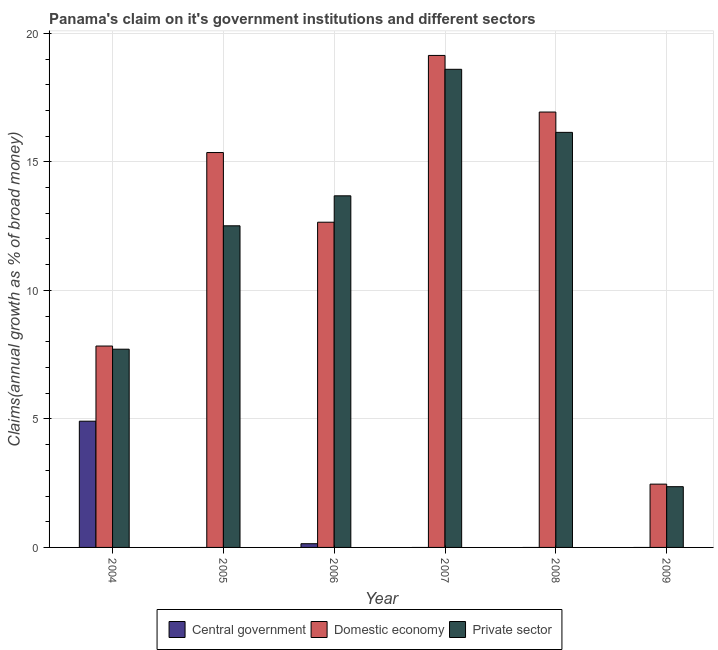How many different coloured bars are there?
Provide a succinct answer. 3. How many bars are there on the 4th tick from the left?
Make the answer very short. 2. Across all years, what is the maximum percentage of claim on the central government?
Give a very brief answer. 4.91. Across all years, what is the minimum percentage of claim on the central government?
Your answer should be compact. 0. In which year was the percentage of claim on the private sector maximum?
Keep it short and to the point. 2007. What is the total percentage of claim on the domestic economy in the graph?
Provide a succinct answer. 74.39. What is the difference between the percentage of claim on the private sector in 2005 and that in 2006?
Provide a short and direct response. -1.17. What is the difference between the percentage of claim on the private sector in 2006 and the percentage of claim on the central government in 2009?
Offer a very short reply. 11.32. What is the average percentage of claim on the central government per year?
Your response must be concise. 0.84. What is the ratio of the percentage of claim on the domestic economy in 2004 to that in 2009?
Your answer should be very brief. 3.18. Is the percentage of claim on the private sector in 2005 less than that in 2009?
Ensure brevity in your answer.  No. What is the difference between the highest and the second highest percentage of claim on the private sector?
Offer a very short reply. 2.45. What is the difference between the highest and the lowest percentage of claim on the domestic economy?
Provide a succinct answer. 16.68. In how many years, is the percentage of claim on the domestic economy greater than the average percentage of claim on the domestic economy taken over all years?
Your answer should be very brief. 4. How many years are there in the graph?
Offer a very short reply. 6. Does the graph contain any zero values?
Make the answer very short. Yes. Does the graph contain grids?
Give a very brief answer. Yes. How are the legend labels stacked?
Offer a very short reply. Horizontal. What is the title of the graph?
Provide a succinct answer. Panama's claim on it's government institutions and different sectors. Does "Injury" appear as one of the legend labels in the graph?
Keep it short and to the point. No. What is the label or title of the X-axis?
Make the answer very short. Year. What is the label or title of the Y-axis?
Give a very brief answer. Claims(annual growth as % of broad money). What is the Claims(annual growth as % of broad money) in Central government in 2004?
Offer a terse response. 4.91. What is the Claims(annual growth as % of broad money) in Domestic economy in 2004?
Your response must be concise. 7.83. What is the Claims(annual growth as % of broad money) of Private sector in 2004?
Your response must be concise. 7.71. What is the Claims(annual growth as % of broad money) of Domestic economy in 2005?
Offer a terse response. 15.36. What is the Claims(annual growth as % of broad money) in Private sector in 2005?
Offer a terse response. 12.51. What is the Claims(annual growth as % of broad money) in Central government in 2006?
Make the answer very short. 0.14. What is the Claims(annual growth as % of broad money) of Domestic economy in 2006?
Provide a succinct answer. 12.65. What is the Claims(annual growth as % of broad money) in Private sector in 2006?
Your answer should be very brief. 13.68. What is the Claims(annual growth as % of broad money) of Domestic economy in 2007?
Your answer should be very brief. 19.14. What is the Claims(annual growth as % of broad money) of Private sector in 2007?
Your response must be concise. 18.6. What is the Claims(annual growth as % of broad money) in Domestic economy in 2008?
Make the answer very short. 16.94. What is the Claims(annual growth as % of broad money) of Private sector in 2008?
Offer a terse response. 16.15. What is the Claims(annual growth as % of broad money) of Domestic economy in 2009?
Offer a terse response. 2.46. What is the Claims(annual growth as % of broad money) of Private sector in 2009?
Your response must be concise. 2.36. Across all years, what is the maximum Claims(annual growth as % of broad money) in Central government?
Make the answer very short. 4.91. Across all years, what is the maximum Claims(annual growth as % of broad money) in Domestic economy?
Your answer should be compact. 19.14. Across all years, what is the maximum Claims(annual growth as % of broad money) in Private sector?
Keep it short and to the point. 18.6. Across all years, what is the minimum Claims(annual growth as % of broad money) of Central government?
Offer a terse response. 0. Across all years, what is the minimum Claims(annual growth as % of broad money) of Domestic economy?
Your response must be concise. 2.46. Across all years, what is the minimum Claims(annual growth as % of broad money) of Private sector?
Offer a terse response. 2.36. What is the total Claims(annual growth as % of broad money) in Central government in the graph?
Offer a very short reply. 5.06. What is the total Claims(annual growth as % of broad money) in Domestic economy in the graph?
Provide a short and direct response. 74.39. What is the total Claims(annual growth as % of broad money) of Private sector in the graph?
Offer a terse response. 71.02. What is the difference between the Claims(annual growth as % of broad money) of Domestic economy in 2004 and that in 2005?
Your response must be concise. -7.53. What is the difference between the Claims(annual growth as % of broad money) of Central government in 2004 and that in 2006?
Keep it short and to the point. 4.77. What is the difference between the Claims(annual growth as % of broad money) in Domestic economy in 2004 and that in 2006?
Offer a very short reply. -4.82. What is the difference between the Claims(annual growth as % of broad money) in Private sector in 2004 and that in 2006?
Keep it short and to the point. -5.97. What is the difference between the Claims(annual growth as % of broad money) of Domestic economy in 2004 and that in 2007?
Ensure brevity in your answer.  -11.31. What is the difference between the Claims(annual growth as % of broad money) in Private sector in 2004 and that in 2007?
Offer a very short reply. -10.89. What is the difference between the Claims(annual growth as % of broad money) in Domestic economy in 2004 and that in 2008?
Give a very brief answer. -9.1. What is the difference between the Claims(annual growth as % of broad money) of Private sector in 2004 and that in 2008?
Offer a terse response. -8.44. What is the difference between the Claims(annual growth as % of broad money) in Domestic economy in 2004 and that in 2009?
Make the answer very short. 5.37. What is the difference between the Claims(annual growth as % of broad money) of Private sector in 2004 and that in 2009?
Your response must be concise. 5.35. What is the difference between the Claims(annual growth as % of broad money) of Domestic economy in 2005 and that in 2006?
Offer a terse response. 2.71. What is the difference between the Claims(annual growth as % of broad money) in Private sector in 2005 and that in 2006?
Provide a short and direct response. -1.17. What is the difference between the Claims(annual growth as % of broad money) in Domestic economy in 2005 and that in 2007?
Provide a succinct answer. -3.78. What is the difference between the Claims(annual growth as % of broad money) in Private sector in 2005 and that in 2007?
Your answer should be very brief. -6.09. What is the difference between the Claims(annual growth as % of broad money) in Domestic economy in 2005 and that in 2008?
Make the answer very short. -1.58. What is the difference between the Claims(annual growth as % of broad money) in Private sector in 2005 and that in 2008?
Your answer should be very brief. -3.64. What is the difference between the Claims(annual growth as % of broad money) in Domestic economy in 2005 and that in 2009?
Keep it short and to the point. 12.9. What is the difference between the Claims(annual growth as % of broad money) in Private sector in 2005 and that in 2009?
Give a very brief answer. 10.15. What is the difference between the Claims(annual growth as % of broad money) in Domestic economy in 2006 and that in 2007?
Provide a succinct answer. -6.49. What is the difference between the Claims(annual growth as % of broad money) in Private sector in 2006 and that in 2007?
Keep it short and to the point. -4.92. What is the difference between the Claims(annual growth as % of broad money) in Domestic economy in 2006 and that in 2008?
Your answer should be very brief. -4.29. What is the difference between the Claims(annual growth as % of broad money) in Private sector in 2006 and that in 2008?
Your answer should be very brief. -2.47. What is the difference between the Claims(annual growth as % of broad money) of Domestic economy in 2006 and that in 2009?
Your answer should be very brief. 10.19. What is the difference between the Claims(annual growth as % of broad money) in Private sector in 2006 and that in 2009?
Your answer should be compact. 11.32. What is the difference between the Claims(annual growth as % of broad money) in Domestic economy in 2007 and that in 2008?
Your answer should be very brief. 2.2. What is the difference between the Claims(annual growth as % of broad money) of Private sector in 2007 and that in 2008?
Offer a very short reply. 2.45. What is the difference between the Claims(annual growth as % of broad money) of Domestic economy in 2007 and that in 2009?
Provide a short and direct response. 16.68. What is the difference between the Claims(annual growth as % of broad money) of Private sector in 2007 and that in 2009?
Make the answer very short. 16.24. What is the difference between the Claims(annual growth as % of broad money) of Domestic economy in 2008 and that in 2009?
Ensure brevity in your answer.  14.48. What is the difference between the Claims(annual growth as % of broad money) in Private sector in 2008 and that in 2009?
Give a very brief answer. 13.78. What is the difference between the Claims(annual growth as % of broad money) in Central government in 2004 and the Claims(annual growth as % of broad money) in Domestic economy in 2005?
Provide a succinct answer. -10.45. What is the difference between the Claims(annual growth as % of broad money) of Central government in 2004 and the Claims(annual growth as % of broad money) of Private sector in 2005?
Keep it short and to the point. -7.6. What is the difference between the Claims(annual growth as % of broad money) of Domestic economy in 2004 and the Claims(annual growth as % of broad money) of Private sector in 2005?
Offer a terse response. -4.68. What is the difference between the Claims(annual growth as % of broad money) in Central government in 2004 and the Claims(annual growth as % of broad money) in Domestic economy in 2006?
Your response must be concise. -7.74. What is the difference between the Claims(annual growth as % of broad money) of Central government in 2004 and the Claims(annual growth as % of broad money) of Private sector in 2006?
Your response must be concise. -8.77. What is the difference between the Claims(annual growth as % of broad money) in Domestic economy in 2004 and the Claims(annual growth as % of broad money) in Private sector in 2006?
Provide a short and direct response. -5.84. What is the difference between the Claims(annual growth as % of broad money) in Central government in 2004 and the Claims(annual growth as % of broad money) in Domestic economy in 2007?
Offer a very short reply. -14.23. What is the difference between the Claims(annual growth as % of broad money) of Central government in 2004 and the Claims(annual growth as % of broad money) of Private sector in 2007?
Your response must be concise. -13.69. What is the difference between the Claims(annual growth as % of broad money) in Domestic economy in 2004 and the Claims(annual growth as % of broad money) in Private sector in 2007?
Offer a very short reply. -10.77. What is the difference between the Claims(annual growth as % of broad money) in Central government in 2004 and the Claims(annual growth as % of broad money) in Domestic economy in 2008?
Provide a succinct answer. -12.03. What is the difference between the Claims(annual growth as % of broad money) in Central government in 2004 and the Claims(annual growth as % of broad money) in Private sector in 2008?
Provide a succinct answer. -11.24. What is the difference between the Claims(annual growth as % of broad money) of Domestic economy in 2004 and the Claims(annual growth as % of broad money) of Private sector in 2008?
Offer a very short reply. -8.31. What is the difference between the Claims(annual growth as % of broad money) in Central government in 2004 and the Claims(annual growth as % of broad money) in Domestic economy in 2009?
Offer a very short reply. 2.45. What is the difference between the Claims(annual growth as % of broad money) in Central government in 2004 and the Claims(annual growth as % of broad money) in Private sector in 2009?
Your response must be concise. 2.55. What is the difference between the Claims(annual growth as % of broad money) in Domestic economy in 2004 and the Claims(annual growth as % of broad money) in Private sector in 2009?
Provide a short and direct response. 5.47. What is the difference between the Claims(annual growth as % of broad money) in Domestic economy in 2005 and the Claims(annual growth as % of broad money) in Private sector in 2006?
Your answer should be compact. 1.68. What is the difference between the Claims(annual growth as % of broad money) of Domestic economy in 2005 and the Claims(annual growth as % of broad money) of Private sector in 2007?
Your answer should be compact. -3.24. What is the difference between the Claims(annual growth as % of broad money) in Domestic economy in 2005 and the Claims(annual growth as % of broad money) in Private sector in 2008?
Provide a short and direct response. -0.78. What is the difference between the Claims(annual growth as % of broad money) of Domestic economy in 2005 and the Claims(annual growth as % of broad money) of Private sector in 2009?
Offer a very short reply. 13. What is the difference between the Claims(annual growth as % of broad money) of Central government in 2006 and the Claims(annual growth as % of broad money) of Domestic economy in 2007?
Offer a terse response. -19. What is the difference between the Claims(annual growth as % of broad money) in Central government in 2006 and the Claims(annual growth as % of broad money) in Private sector in 2007?
Offer a very short reply. -18.46. What is the difference between the Claims(annual growth as % of broad money) in Domestic economy in 2006 and the Claims(annual growth as % of broad money) in Private sector in 2007?
Give a very brief answer. -5.95. What is the difference between the Claims(annual growth as % of broad money) of Central government in 2006 and the Claims(annual growth as % of broad money) of Domestic economy in 2008?
Provide a short and direct response. -16.79. What is the difference between the Claims(annual growth as % of broad money) in Central government in 2006 and the Claims(annual growth as % of broad money) in Private sector in 2008?
Your answer should be compact. -16. What is the difference between the Claims(annual growth as % of broad money) in Domestic economy in 2006 and the Claims(annual growth as % of broad money) in Private sector in 2008?
Make the answer very short. -3.5. What is the difference between the Claims(annual growth as % of broad money) of Central government in 2006 and the Claims(annual growth as % of broad money) of Domestic economy in 2009?
Provide a succinct answer. -2.32. What is the difference between the Claims(annual growth as % of broad money) in Central government in 2006 and the Claims(annual growth as % of broad money) in Private sector in 2009?
Provide a succinct answer. -2.22. What is the difference between the Claims(annual growth as % of broad money) in Domestic economy in 2006 and the Claims(annual growth as % of broad money) in Private sector in 2009?
Give a very brief answer. 10.29. What is the difference between the Claims(annual growth as % of broad money) in Domestic economy in 2007 and the Claims(annual growth as % of broad money) in Private sector in 2008?
Your answer should be very brief. 2.99. What is the difference between the Claims(annual growth as % of broad money) in Domestic economy in 2007 and the Claims(annual growth as % of broad money) in Private sector in 2009?
Make the answer very short. 16.78. What is the difference between the Claims(annual growth as % of broad money) of Domestic economy in 2008 and the Claims(annual growth as % of broad money) of Private sector in 2009?
Provide a short and direct response. 14.58. What is the average Claims(annual growth as % of broad money) of Central government per year?
Make the answer very short. 0.84. What is the average Claims(annual growth as % of broad money) in Domestic economy per year?
Provide a short and direct response. 12.4. What is the average Claims(annual growth as % of broad money) of Private sector per year?
Keep it short and to the point. 11.84. In the year 2004, what is the difference between the Claims(annual growth as % of broad money) in Central government and Claims(annual growth as % of broad money) in Domestic economy?
Keep it short and to the point. -2.92. In the year 2004, what is the difference between the Claims(annual growth as % of broad money) in Central government and Claims(annual growth as % of broad money) in Private sector?
Provide a short and direct response. -2.8. In the year 2004, what is the difference between the Claims(annual growth as % of broad money) in Domestic economy and Claims(annual growth as % of broad money) in Private sector?
Your answer should be compact. 0.12. In the year 2005, what is the difference between the Claims(annual growth as % of broad money) of Domestic economy and Claims(annual growth as % of broad money) of Private sector?
Offer a very short reply. 2.85. In the year 2006, what is the difference between the Claims(annual growth as % of broad money) in Central government and Claims(annual growth as % of broad money) in Domestic economy?
Ensure brevity in your answer.  -12.51. In the year 2006, what is the difference between the Claims(annual growth as % of broad money) of Central government and Claims(annual growth as % of broad money) of Private sector?
Your answer should be very brief. -13.53. In the year 2006, what is the difference between the Claims(annual growth as % of broad money) in Domestic economy and Claims(annual growth as % of broad money) in Private sector?
Your response must be concise. -1.03. In the year 2007, what is the difference between the Claims(annual growth as % of broad money) in Domestic economy and Claims(annual growth as % of broad money) in Private sector?
Provide a short and direct response. 0.54. In the year 2008, what is the difference between the Claims(annual growth as % of broad money) in Domestic economy and Claims(annual growth as % of broad money) in Private sector?
Your answer should be very brief. 0.79. In the year 2009, what is the difference between the Claims(annual growth as % of broad money) in Domestic economy and Claims(annual growth as % of broad money) in Private sector?
Ensure brevity in your answer.  0.1. What is the ratio of the Claims(annual growth as % of broad money) of Domestic economy in 2004 to that in 2005?
Keep it short and to the point. 0.51. What is the ratio of the Claims(annual growth as % of broad money) in Private sector in 2004 to that in 2005?
Ensure brevity in your answer.  0.62. What is the ratio of the Claims(annual growth as % of broad money) of Central government in 2004 to that in 2006?
Give a very brief answer. 34.04. What is the ratio of the Claims(annual growth as % of broad money) of Domestic economy in 2004 to that in 2006?
Provide a succinct answer. 0.62. What is the ratio of the Claims(annual growth as % of broad money) in Private sector in 2004 to that in 2006?
Provide a succinct answer. 0.56. What is the ratio of the Claims(annual growth as % of broad money) in Domestic economy in 2004 to that in 2007?
Your response must be concise. 0.41. What is the ratio of the Claims(annual growth as % of broad money) of Private sector in 2004 to that in 2007?
Provide a short and direct response. 0.41. What is the ratio of the Claims(annual growth as % of broad money) in Domestic economy in 2004 to that in 2008?
Keep it short and to the point. 0.46. What is the ratio of the Claims(annual growth as % of broad money) of Private sector in 2004 to that in 2008?
Keep it short and to the point. 0.48. What is the ratio of the Claims(annual growth as % of broad money) of Domestic economy in 2004 to that in 2009?
Offer a very short reply. 3.18. What is the ratio of the Claims(annual growth as % of broad money) in Private sector in 2004 to that in 2009?
Make the answer very short. 3.26. What is the ratio of the Claims(annual growth as % of broad money) of Domestic economy in 2005 to that in 2006?
Offer a terse response. 1.21. What is the ratio of the Claims(annual growth as % of broad money) of Private sector in 2005 to that in 2006?
Keep it short and to the point. 0.91. What is the ratio of the Claims(annual growth as % of broad money) of Domestic economy in 2005 to that in 2007?
Make the answer very short. 0.8. What is the ratio of the Claims(annual growth as % of broad money) of Private sector in 2005 to that in 2007?
Your answer should be compact. 0.67. What is the ratio of the Claims(annual growth as % of broad money) of Domestic economy in 2005 to that in 2008?
Ensure brevity in your answer.  0.91. What is the ratio of the Claims(annual growth as % of broad money) of Private sector in 2005 to that in 2008?
Your answer should be compact. 0.77. What is the ratio of the Claims(annual growth as % of broad money) in Domestic economy in 2005 to that in 2009?
Your answer should be compact. 6.24. What is the ratio of the Claims(annual growth as % of broad money) in Private sector in 2005 to that in 2009?
Your response must be concise. 5.29. What is the ratio of the Claims(annual growth as % of broad money) in Domestic economy in 2006 to that in 2007?
Ensure brevity in your answer.  0.66. What is the ratio of the Claims(annual growth as % of broad money) in Private sector in 2006 to that in 2007?
Provide a short and direct response. 0.74. What is the ratio of the Claims(annual growth as % of broad money) in Domestic economy in 2006 to that in 2008?
Provide a succinct answer. 0.75. What is the ratio of the Claims(annual growth as % of broad money) of Private sector in 2006 to that in 2008?
Your answer should be very brief. 0.85. What is the ratio of the Claims(annual growth as % of broad money) in Domestic economy in 2006 to that in 2009?
Make the answer very short. 5.14. What is the ratio of the Claims(annual growth as % of broad money) in Private sector in 2006 to that in 2009?
Your answer should be very brief. 5.79. What is the ratio of the Claims(annual growth as % of broad money) of Domestic economy in 2007 to that in 2008?
Offer a very short reply. 1.13. What is the ratio of the Claims(annual growth as % of broad money) of Private sector in 2007 to that in 2008?
Give a very brief answer. 1.15. What is the ratio of the Claims(annual growth as % of broad money) of Domestic economy in 2007 to that in 2009?
Give a very brief answer. 7.77. What is the ratio of the Claims(annual growth as % of broad money) of Private sector in 2007 to that in 2009?
Your answer should be compact. 7.87. What is the ratio of the Claims(annual growth as % of broad money) in Domestic economy in 2008 to that in 2009?
Your response must be concise. 6.88. What is the ratio of the Claims(annual growth as % of broad money) of Private sector in 2008 to that in 2009?
Provide a short and direct response. 6.83. What is the difference between the highest and the second highest Claims(annual growth as % of broad money) of Domestic economy?
Offer a terse response. 2.2. What is the difference between the highest and the second highest Claims(annual growth as % of broad money) in Private sector?
Give a very brief answer. 2.45. What is the difference between the highest and the lowest Claims(annual growth as % of broad money) of Central government?
Your answer should be very brief. 4.91. What is the difference between the highest and the lowest Claims(annual growth as % of broad money) in Domestic economy?
Make the answer very short. 16.68. What is the difference between the highest and the lowest Claims(annual growth as % of broad money) in Private sector?
Give a very brief answer. 16.24. 